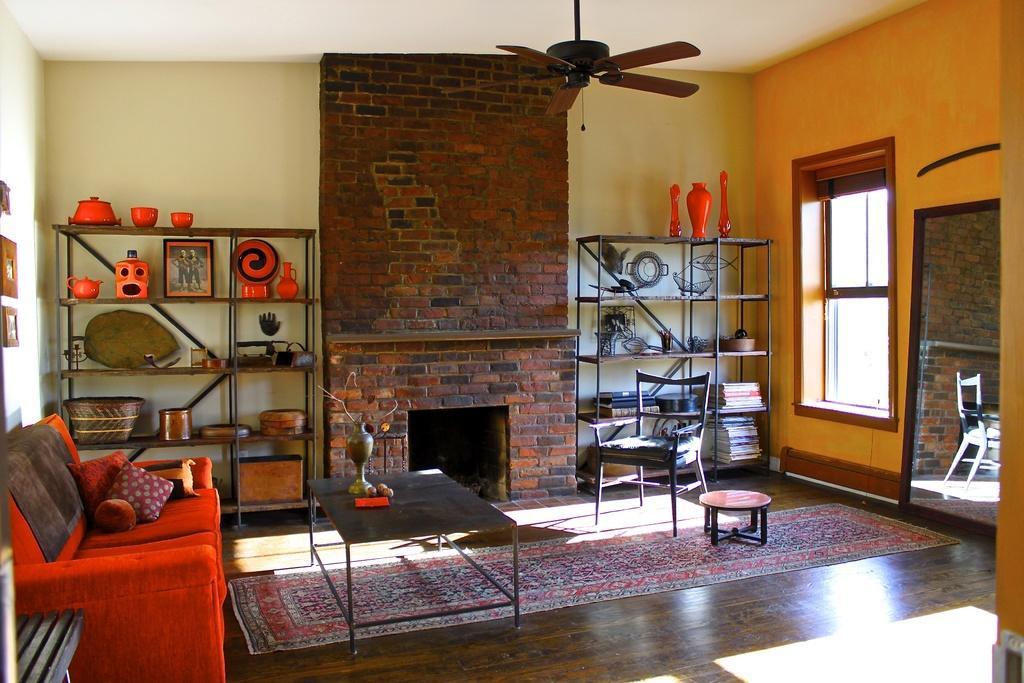Please provide a concise description of this image. There is a room in the given picture where there are sofas, tables, cup boards and shelves, in which some books are placed. There is a chair. There is a place for fire here. There is a ceiling fan and in the background we can observe a wall and a window here. 